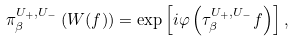<formula> <loc_0><loc_0><loc_500><loc_500>\pi _ { \beta } ^ { U _ { + } , U _ { - } } \left ( W ( f ) \right ) = \exp \left [ i \varphi \left ( \tau _ { \beta } ^ { U _ { + } , U _ { - } } f \right ) \right ] ,</formula> 